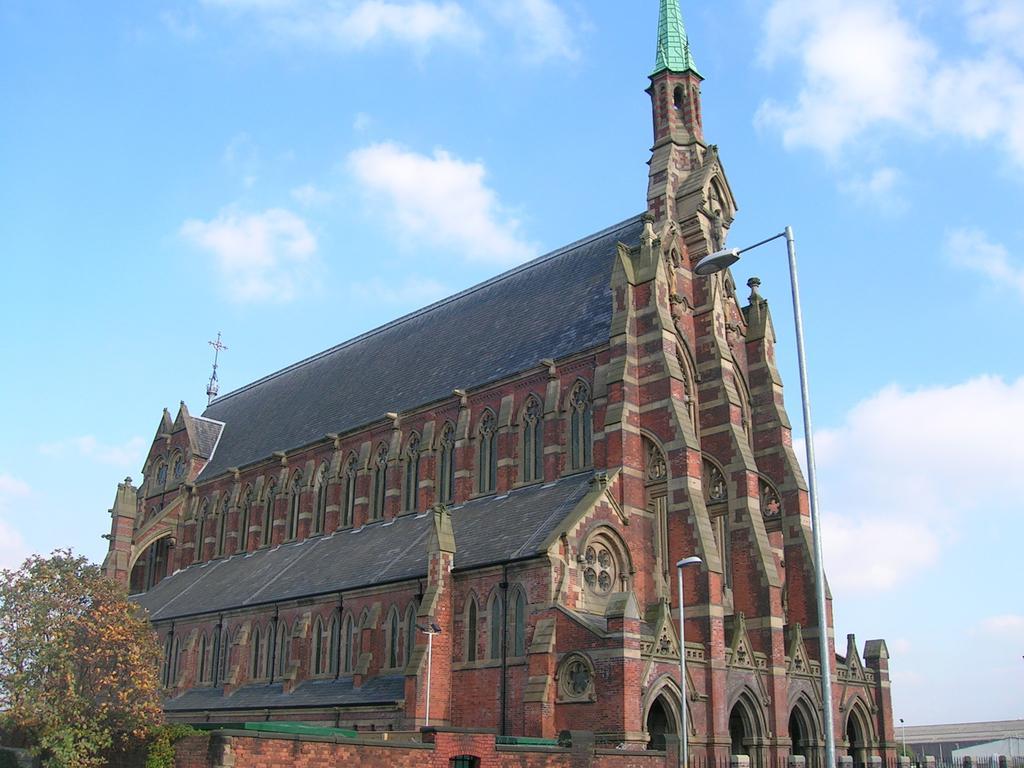Please provide a concise description of this image. In the foreground of this image, there are two poles, a tree on the left and a building. At the top, there is the sky. 